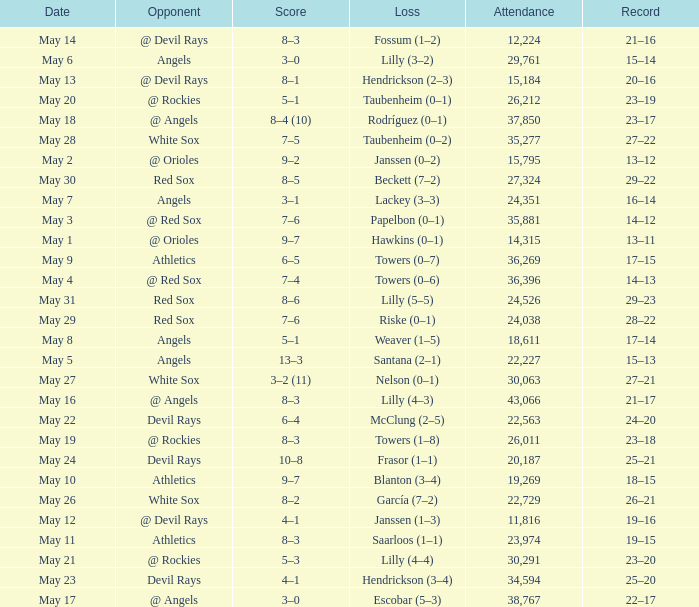Parse the table in full. {'header': ['Date', 'Opponent', 'Score', 'Loss', 'Attendance', 'Record'], 'rows': [['May 14', '@ Devil Rays', '8–3', 'Fossum (1–2)', '12,224', '21–16'], ['May 6', 'Angels', '3–0', 'Lilly (3–2)', '29,761', '15–14'], ['May 13', '@ Devil Rays', '8–1', 'Hendrickson (2–3)', '15,184', '20–16'], ['May 20', '@ Rockies', '5–1', 'Taubenheim (0–1)', '26,212', '23–19'], ['May 18', '@ Angels', '8–4 (10)', 'Rodríguez (0–1)', '37,850', '23–17'], ['May 28', 'White Sox', '7–5', 'Taubenheim (0–2)', '35,277', '27–22'], ['May 2', '@ Orioles', '9–2', 'Janssen (0–2)', '15,795', '13–12'], ['May 30', 'Red Sox', '8–5', 'Beckett (7–2)', '27,324', '29–22'], ['May 7', 'Angels', '3–1', 'Lackey (3–3)', '24,351', '16–14'], ['May 3', '@ Red Sox', '7–6', 'Papelbon (0–1)', '35,881', '14–12'], ['May 1', '@ Orioles', '9–7', 'Hawkins (0–1)', '14,315', '13–11'], ['May 9', 'Athletics', '6–5', 'Towers (0–7)', '36,269', '17–15'], ['May 4', '@ Red Sox', '7–4', 'Towers (0–6)', '36,396', '14–13'], ['May 31', 'Red Sox', '8–6', 'Lilly (5–5)', '24,526', '29–23'], ['May 29', 'Red Sox', '7–6', 'Riske (0–1)', '24,038', '28–22'], ['May 8', 'Angels', '5–1', 'Weaver (1–5)', '18,611', '17–14'], ['May 5', 'Angels', '13–3', 'Santana (2–1)', '22,227', '15–13'], ['May 27', 'White Sox', '3–2 (11)', 'Nelson (0–1)', '30,063', '27–21'], ['May 16', '@ Angels', '8–3', 'Lilly (4–3)', '43,066', '21–17'], ['May 22', 'Devil Rays', '6–4', 'McClung (2–5)', '22,563', '24–20'], ['May 19', '@ Rockies', '8–3', 'Towers (1–8)', '26,011', '23–18'], ['May 24', 'Devil Rays', '10–8', 'Frasor (1–1)', '20,187', '25–21'], ['May 10', 'Athletics', '9–7', 'Blanton (3–4)', '19,269', '18–15'], ['May 26', 'White Sox', '8–2', 'García (7–2)', '22,729', '26–21'], ['May 12', '@ Devil Rays', '4–1', 'Janssen (1–3)', '11,816', '19–16'], ['May 11', 'Athletics', '8–3', 'Saarloos (1–1)', '23,974', '19–15'], ['May 21', '@ Rockies', '5–3', 'Lilly (4–4)', '30,291', '23–20'], ['May 23', 'Devil Rays', '4–1', 'Hendrickson (3–4)', '34,594', '25–20'], ['May 17', '@ Angels', '3–0', 'Escobar (5–3)', '38,767', '22–17']]} When the team had their record of 16–14, what was the total attendance? 1.0. 